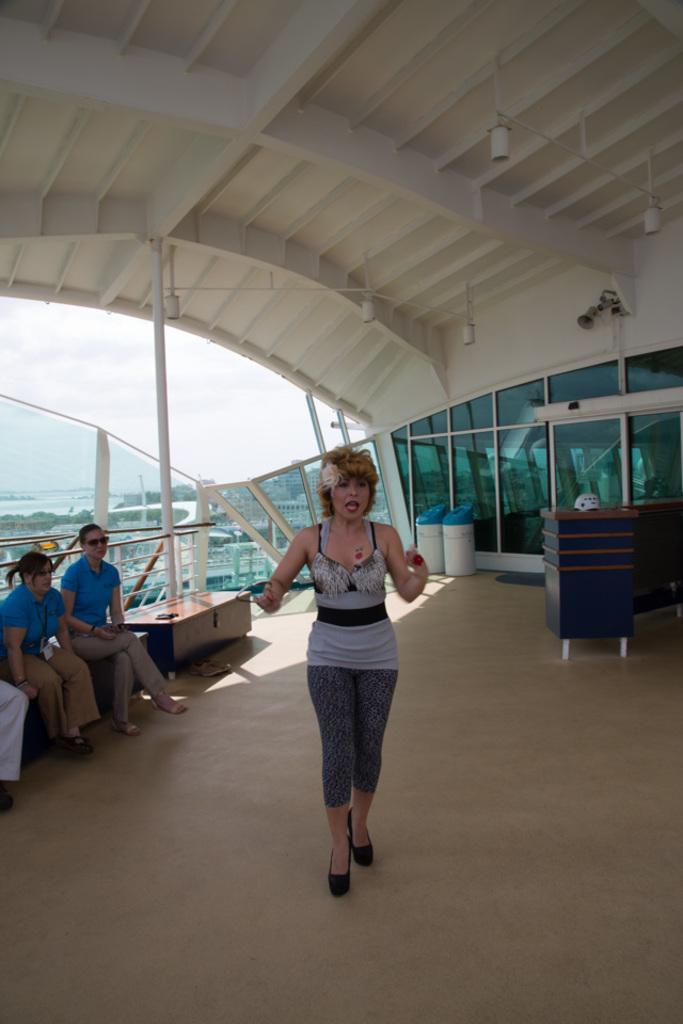Can you describe this image briefly? In this picture we can see a woman on the ground, here we can see people sitting on a platform and we can see a roof and some objects and in the background we can see trees, sky and some objects. 